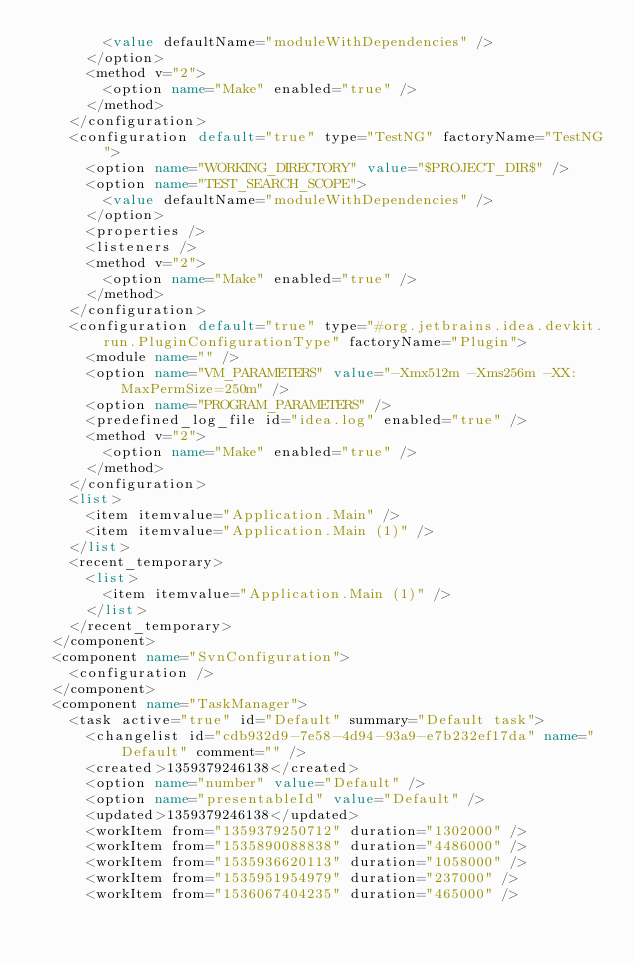Convert code to text. <code><loc_0><loc_0><loc_500><loc_500><_XML_>        <value defaultName="moduleWithDependencies" />
      </option>
      <method v="2">
        <option name="Make" enabled="true" />
      </method>
    </configuration>
    <configuration default="true" type="TestNG" factoryName="TestNG">
      <option name="WORKING_DIRECTORY" value="$PROJECT_DIR$" />
      <option name="TEST_SEARCH_SCOPE">
        <value defaultName="moduleWithDependencies" />
      </option>
      <properties />
      <listeners />
      <method v="2">
        <option name="Make" enabled="true" />
      </method>
    </configuration>
    <configuration default="true" type="#org.jetbrains.idea.devkit.run.PluginConfigurationType" factoryName="Plugin">
      <module name="" />
      <option name="VM_PARAMETERS" value="-Xmx512m -Xms256m -XX:MaxPermSize=250m" />
      <option name="PROGRAM_PARAMETERS" />
      <predefined_log_file id="idea.log" enabled="true" />
      <method v="2">
        <option name="Make" enabled="true" />
      </method>
    </configuration>
    <list>
      <item itemvalue="Application.Main" />
      <item itemvalue="Application.Main (1)" />
    </list>
    <recent_temporary>
      <list>
        <item itemvalue="Application.Main (1)" />
      </list>
    </recent_temporary>
  </component>
  <component name="SvnConfiguration">
    <configuration />
  </component>
  <component name="TaskManager">
    <task active="true" id="Default" summary="Default task">
      <changelist id="cdb932d9-7e58-4d94-93a9-e7b232ef17da" name="Default" comment="" />
      <created>1359379246138</created>
      <option name="number" value="Default" />
      <option name="presentableId" value="Default" />
      <updated>1359379246138</updated>
      <workItem from="1359379250712" duration="1302000" />
      <workItem from="1535890088838" duration="4486000" />
      <workItem from="1535936620113" duration="1058000" />
      <workItem from="1535951954979" duration="237000" />
      <workItem from="1536067404235" duration="465000" /></code> 